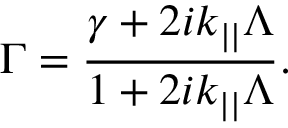<formula> <loc_0><loc_0><loc_500><loc_500>\Gamma = \frac { \gamma + 2 i k _ { | | } \Lambda } { 1 + 2 i k _ { | | } \Lambda } .</formula> 